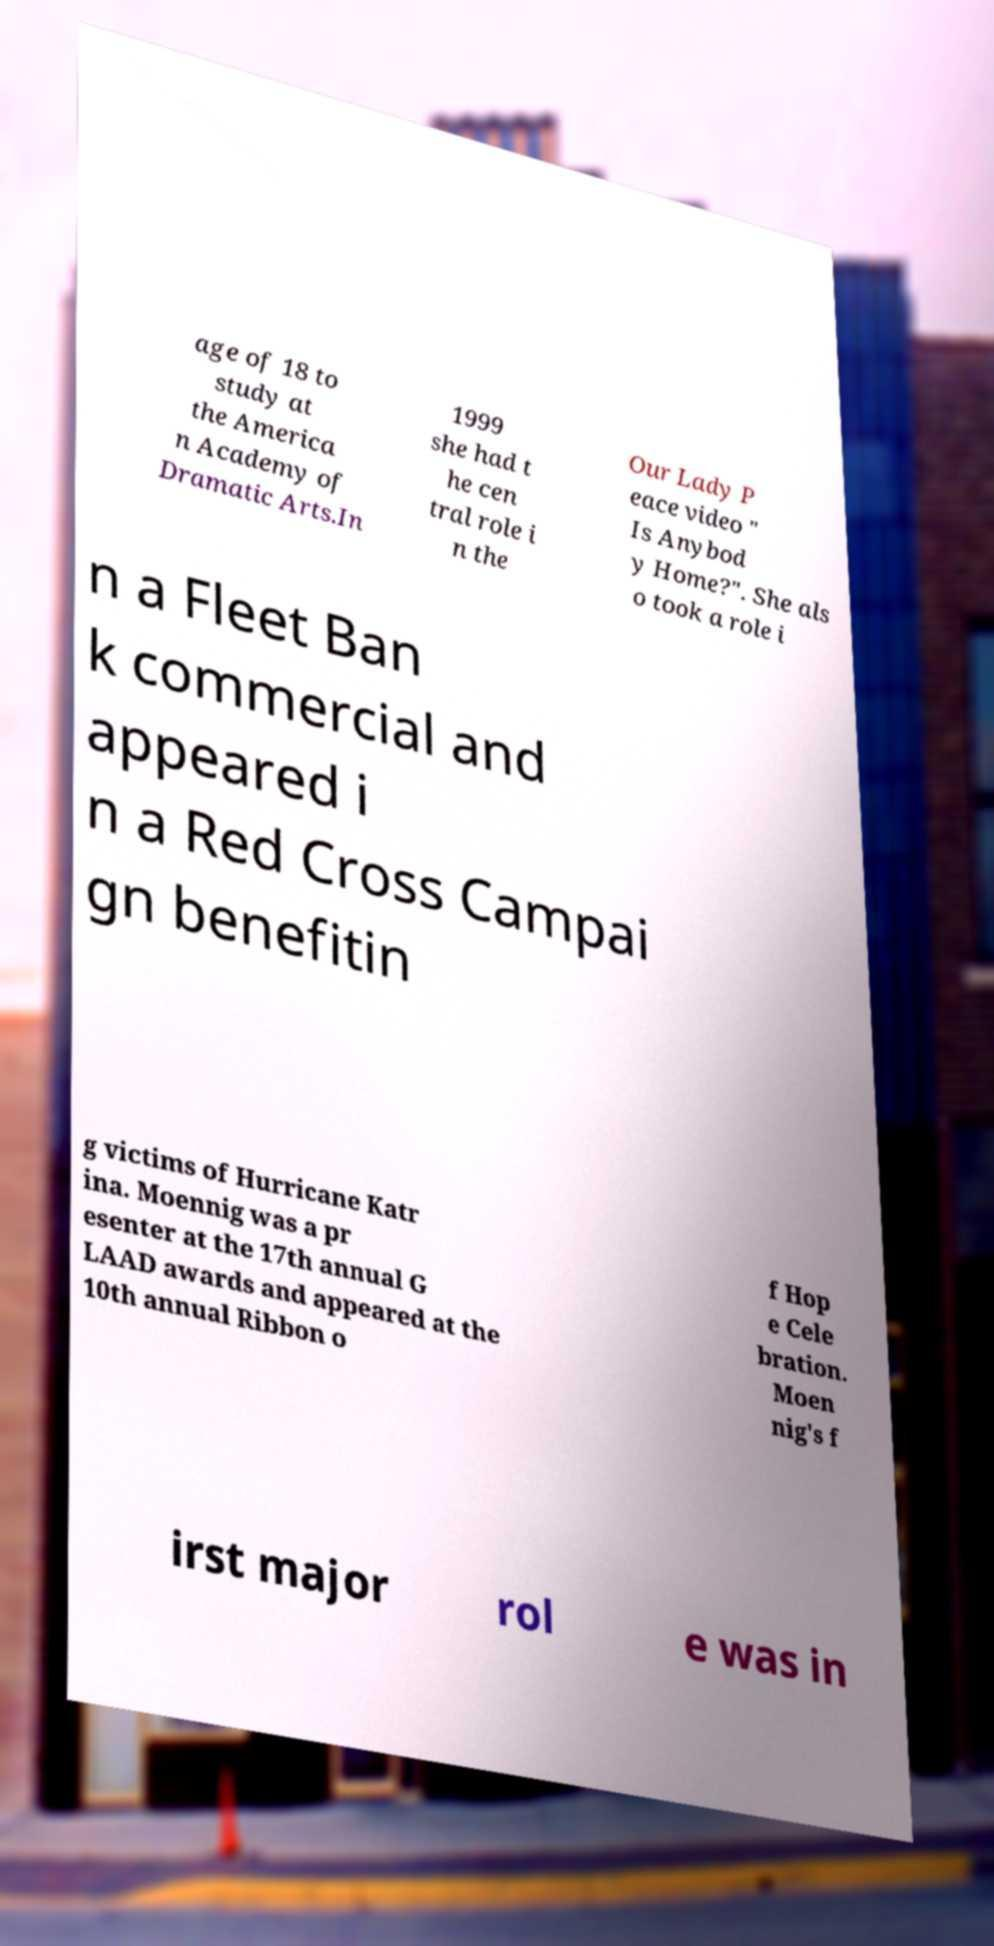What messages or text are displayed in this image? I need them in a readable, typed format. age of 18 to study at the America n Academy of Dramatic Arts.In 1999 she had t he cen tral role i n the Our Lady P eace video " Is Anybod y Home?". She als o took a role i n a Fleet Ban k commercial and appeared i n a Red Cross Campai gn benefitin g victims of Hurricane Katr ina. Moennig was a pr esenter at the 17th annual G LAAD awards and appeared at the 10th annual Ribbon o f Hop e Cele bration. Moen nig's f irst major rol e was in 